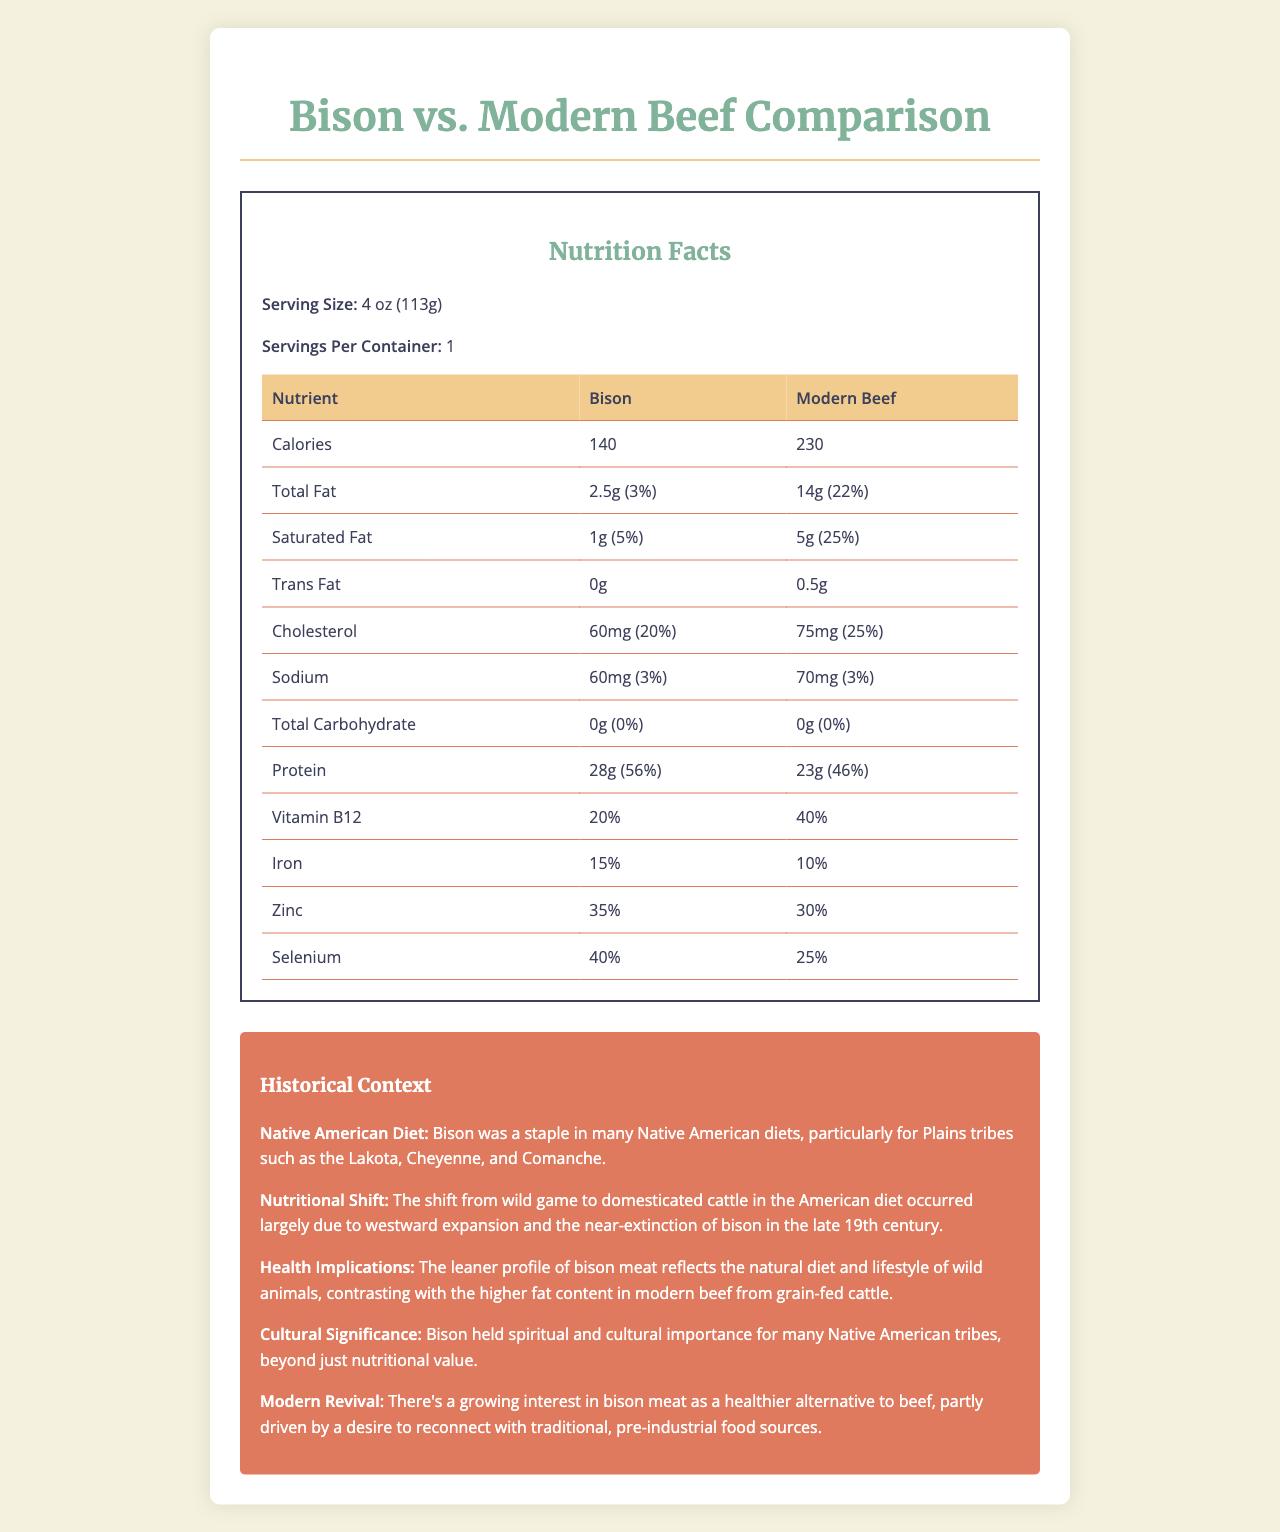what is the calorie difference between bison and modern beef per serving? The document shows that bison has 140 calories and modern beef has 230 calories. The difference is 230 - 140 = 90 calories.
Answer: 90 calories how much total fat does bison contain per serving? The "Total Fat" row indicates that bison contains 2.5 grams of total fat per serving.
Answer: 2.5 grams which meat has more protein, bison or modern beef? The document states that bison has 28 grams of protein per serving, while modern beef has 23 grams. Therefore, bison has more protein.
Answer: Bison why did the nutritional profile of meat shift in the American diet? The "Nutritional Shift" section in the historical context explains that the shift was due to westward expansion and the near-extinction of bison in the late 19th century.
Answer: Westward expansion and near-extinction of bison what is the daily value percentage of saturated fat in modern beef? The "Saturated Fat" row for modern beef indicates that it has a daily value of 25%.
Answer: 25% which vitamin is present in a higher amount in modern beef compared to bison? A. Vitamin B12 B. Iron C. Zinc The document states that modern beef has 40% of the daily value for Vitamin B12, compared to 20% in bison.
Answer: A which meat has a higher selenium content, bison or modern beef? According to the document, bison has 40% of the daily value for selenium, whereas modern beef has 25%.
Answer: Bison how much sodium is found in a serving of modern beef? The "Sodium" row shows that modern beef contains 70 milligrams of sodium per serving.
Answer: 70 milligrams does bison meat have any trans fat? The document indicates that bison has 0 grams of trans fat.
Answer: No compare the health implications of consuming bison meat versus modern beef. The "Health Implications" section states that bison's leaner profile reflects the natural diet and lifestyle of wild animals, contrasting with modern beef's higher fat content from grain-fed cattle.
Answer: Bison is leaner and reflects a natural diet, whereas modern beef has a higher fat content from grain-fed cattle. which meat was a staple in Native American diets? A. Modern Beef B. Bison C. Chicken The "Native American Diet" section states that bison was a staple in many Native American diets.
Answer: B is the protein content higher in bison meat compared to modern beef? The document clearly states that bison has 28 grams of protein, while modern beef has 23 grams per serving.
Answer: Yes summary: describe the main idea of the document. This summary captures the key nutritional comparisons and historical context presented in the document.
Answer: The document compares the nutritional content of bison meat to modern beef, highlighting the historical context and dietary differences between Native American diets and modern American diets. It shows that bison is leaner with higher protein and lower fat, while modern beef has a higher caloric and fat content. The document also discusses the health and cultural significance of bison to Native American tribes and the resurgence of bison as a healthier alternative. what factors led to the inclusion of modern beef in American diets over bison? Although the document mentions the shift due to westward expansion and the near-extinction of bison, it does not provide a detailed account of all factors leading to the inclusion of modern beef in American diets.
Answer: Not enough information 